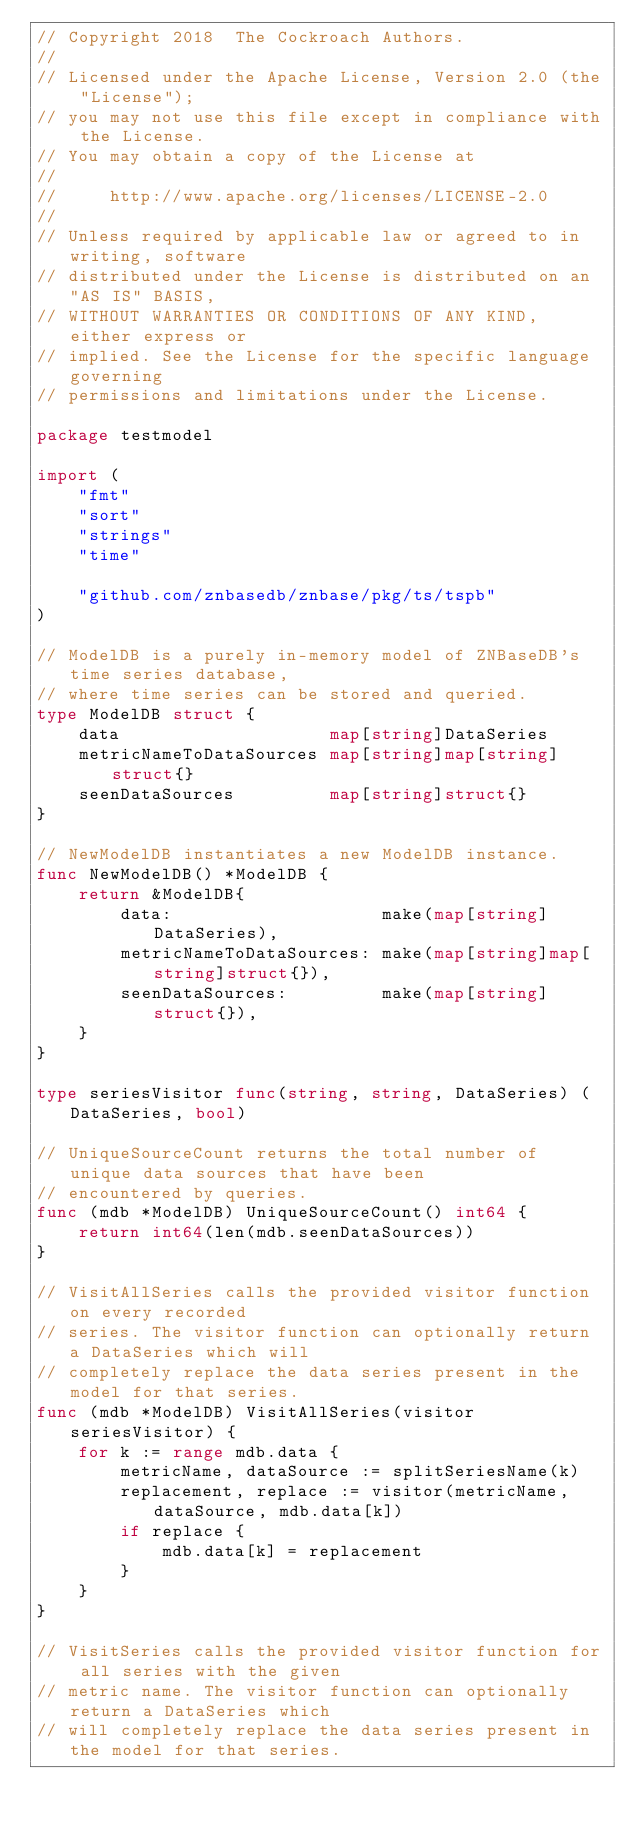<code> <loc_0><loc_0><loc_500><loc_500><_Go_>// Copyright 2018  The Cockroach Authors.
//
// Licensed under the Apache License, Version 2.0 (the "License");
// you may not use this file except in compliance with the License.
// You may obtain a copy of the License at
//
//     http://www.apache.org/licenses/LICENSE-2.0
//
// Unless required by applicable law or agreed to in writing, software
// distributed under the License is distributed on an "AS IS" BASIS,
// WITHOUT WARRANTIES OR CONDITIONS OF ANY KIND, either express or
// implied. See the License for the specific language governing
// permissions and limitations under the License.

package testmodel

import (
	"fmt"
	"sort"
	"strings"
	"time"

	"github.com/znbasedb/znbase/pkg/ts/tspb"
)

// ModelDB is a purely in-memory model of ZNBaseDB's time series database,
// where time series can be stored and queried.
type ModelDB struct {
	data                    map[string]DataSeries
	metricNameToDataSources map[string]map[string]struct{}
	seenDataSources         map[string]struct{}
}

// NewModelDB instantiates a new ModelDB instance.
func NewModelDB() *ModelDB {
	return &ModelDB{
		data:                    make(map[string]DataSeries),
		metricNameToDataSources: make(map[string]map[string]struct{}),
		seenDataSources:         make(map[string]struct{}),
	}
}

type seriesVisitor func(string, string, DataSeries) (DataSeries, bool)

// UniqueSourceCount returns the total number of unique data sources that have been
// encountered by queries.
func (mdb *ModelDB) UniqueSourceCount() int64 {
	return int64(len(mdb.seenDataSources))
}

// VisitAllSeries calls the provided visitor function on every recorded
// series. The visitor function can optionally return a DataSeries which will
// completely replace the data series present in the model for that series.
func (mdb *ModelDB) VisitAllSeries(visitor seriesVisitor) {
	for k := range mdb.data {
		metricName, dataSource := splitSeriesName(k)
		replacement, replace := visitor(metricName, dataSource, mdb.data[k])
		if replace {
			mdb.data[k] = replacement
		}
	}
}

// VisitSeries calls the provided visitor function for all series with the given
// metric name. The visitor function can optionally return a DataSeries which
// will completely replace the data series present in the model for that series.</code> 